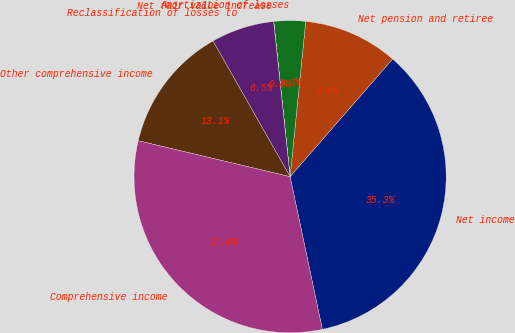<chart> <loc_0><loc_0><loc_500><loc_500><pie_chart><fcel>Net income<fcel>Net pension and retiree<fcel>Amortization of losses<fcel>Net fair value increase<fcel>Reclassification of losses to<fcel>Other comprehensive income<fcel>Comprehensive income<nl><fcel>35.28%<fcel>9.81%<fcel>3.27%<fcel>0.01%<fcel>6.54%<fcel>13.08%<fcel>32.01%<nl></chart> 